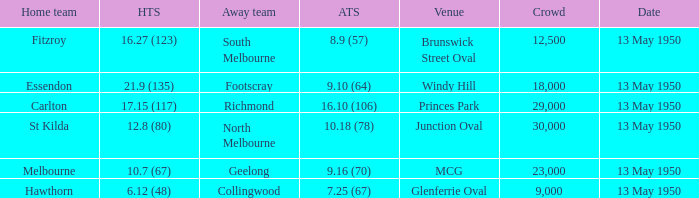What was the away team's score when Fitzroy's score was 16.27 (123) on May 13, 1950. 8.9 (57). 